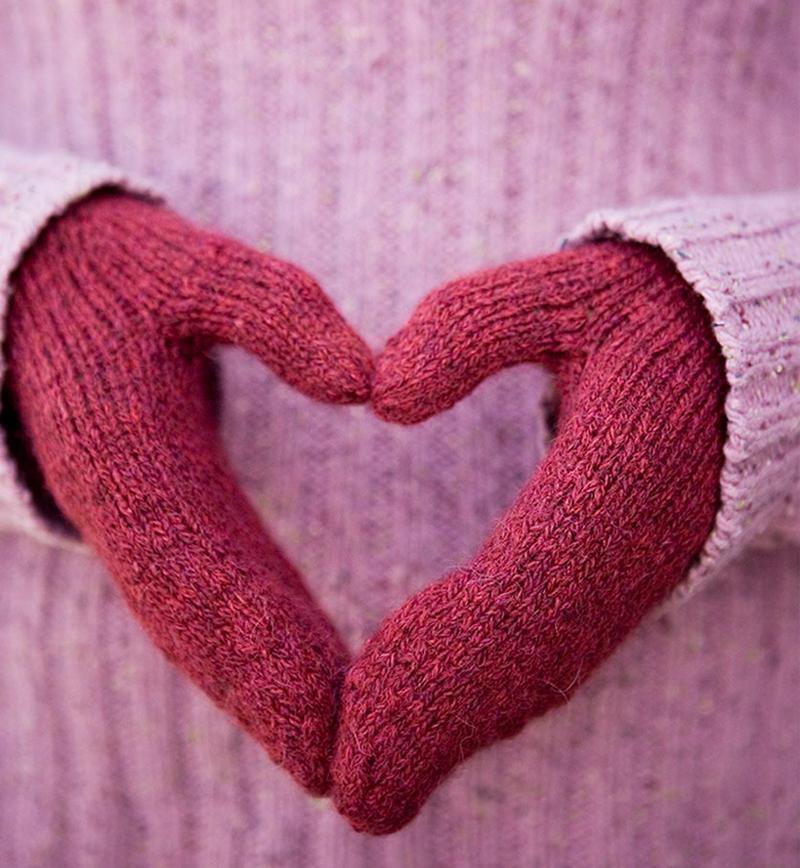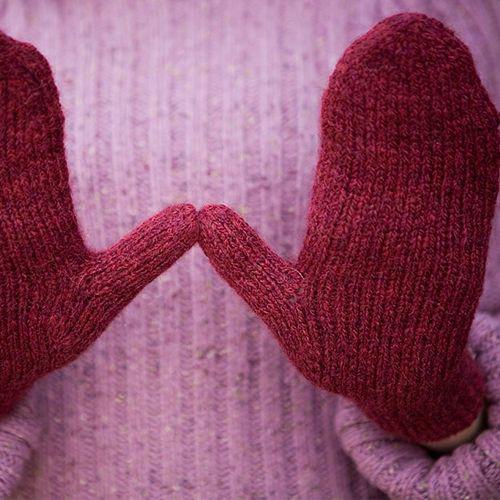The first image is the image on the left, the second image is the image on the right. Analyze the images presented: Is the assertion "The mittens in the image on the right have hands in them." valid? Answer yes or no. Yes. 